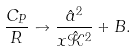Convert formula to latex. <formula><loc_0><loc_0><loc_500><loc_500>\frac { C _ { P } } { R } \to \frac { \hat { a } ^ { 2 } } { x \hat { \mathcal { K } } ^ { 2 } } + B .</formula> 